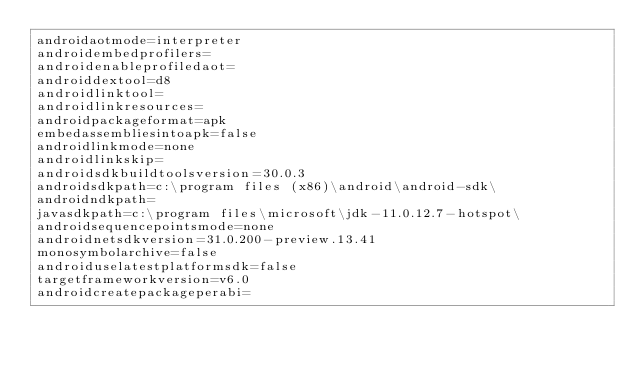Convert code to text. <code><loc_0><loc_0><loc_500><loc_500><_XML_>androidaotmode=interpreter
androidembedprofilers=
androidenableprofiledaot=
androiddextool=d8
androidlinktool=
androidlinkresources=
androidpackageformat=apk
embedassembliesintoapk=false
androidlinkmode=none
androidlinkskip=
androidsdkbuildtoolsversion=30.0.3
androidsdkpath=c:\program files (x86)\android\android-sdk\
androidndkpath=
javasdkpath=c:\program files\microsoft\jdk-11.0.12.7-hotspot\
androidsequencepointsmode=none
androidnetsdkversion=31.0.200-preview.13.41
monosymbolarchive=false
androiduselatestplatformsdk=false
targetframeworkversion=v6.0
androidcreatepackageperabi=</code> 